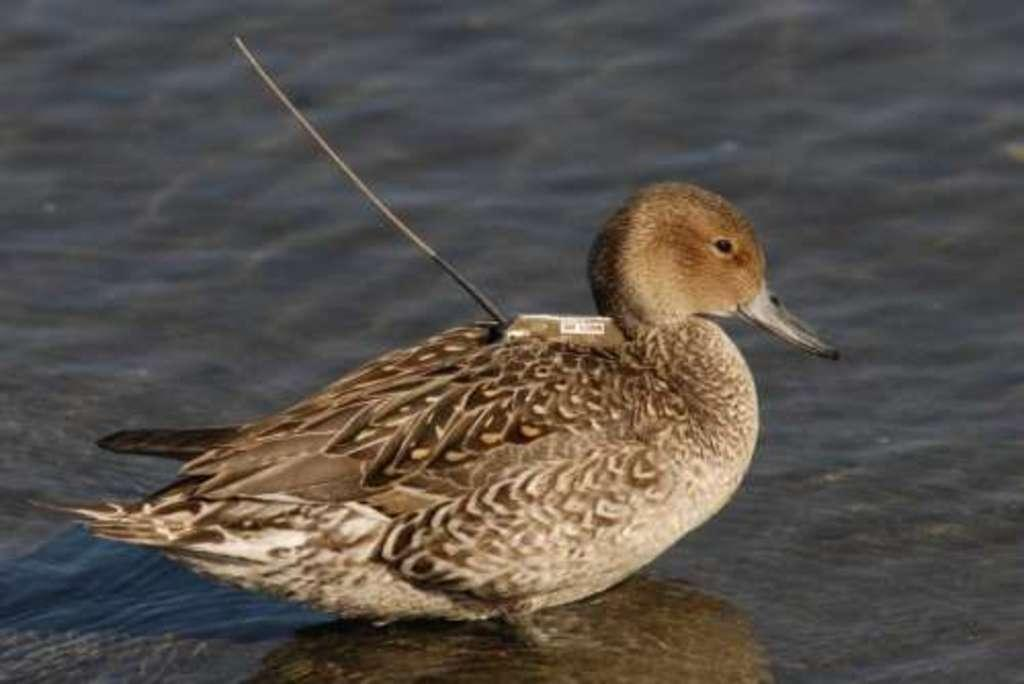What type of animal is in the image? There is a bird in the image. Where is the bird located in the image? The bird is in the front of the image. What can be seen in the background of the image? There is water visible in the background of the image. What type of toothbrush is the bird using in the image? There is no toothbrush present in the image, and therefore the bird is not using one. 